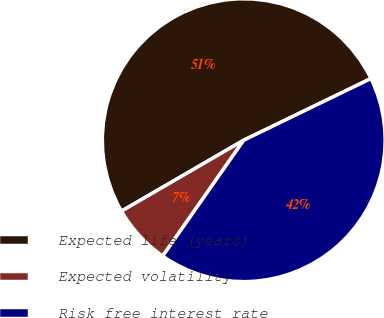Convert chart to OTSL. <chart><loc_0><loc_0><loc_500><loc_500><pie_chart><fcel>Expected life (years)<fcel>Expected volatility<fcel>Risk free interest rate<nl><fcel>51.18%<fcel>6.92%<fcel>41.89%<nl></chart> 